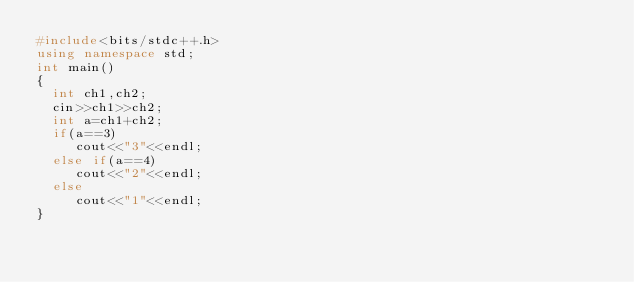Convert code to text. <code><loc_0><loc_0><loc_500><loc_500><_C++_>#include<bits/stdc++.h>
using namespace std;
int main()
{
  int ch1,ch2;
  cin>>ch1>>ch2;
  int a=ch1+ch2;
  if(a==3)
     cout<<"3"<<endl;
  else if(a==4)
     cout<<"2"<<endl;
  else 
     cout<<"1"<<endl;
}
</code> 